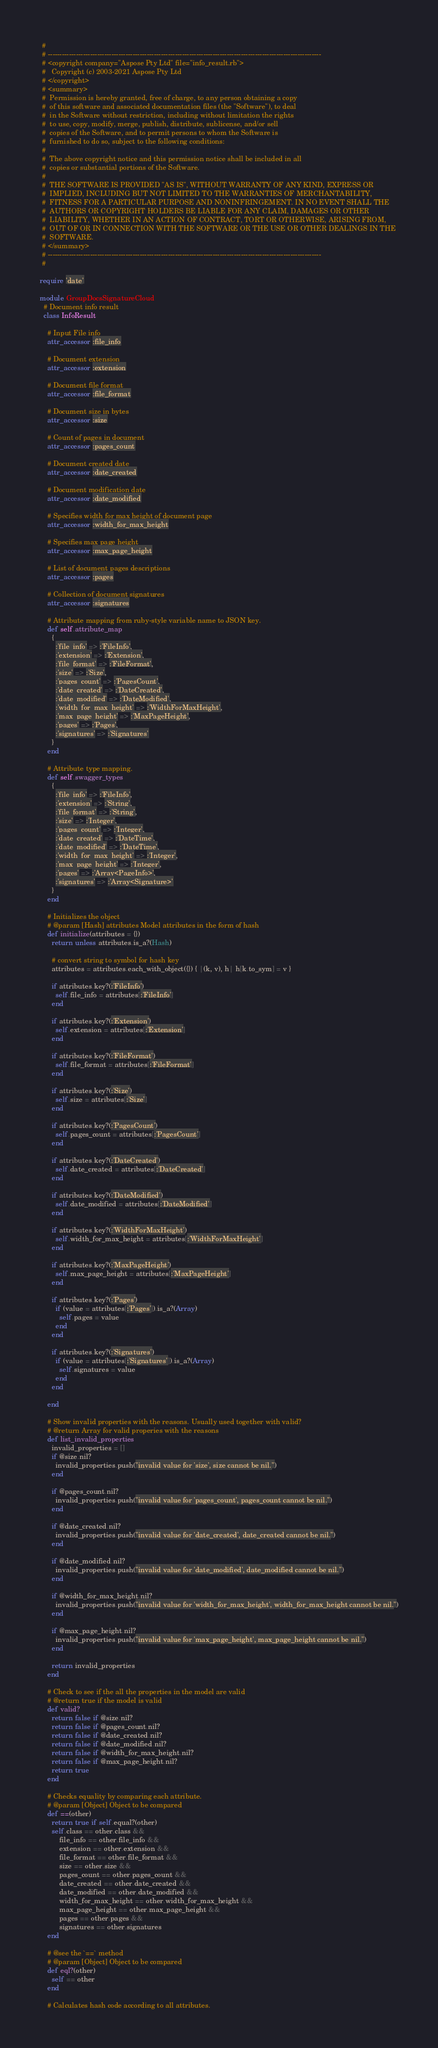Convert code to text. <code><loc_0><loc_0><loc_500><loc_500><_Ruby_> #
 # --------------------------------------------------------------------------------------------------------------------
 # <copyright company="Aspose Pty Ltd" file="info_result.rb">
 #   Copyright (c) 2003-2021 Aspose Pty Ltd
 # </copyright>
 # <summary>
 #  Permission is hereby granted, free of charge, to any person obtaining a copy
 #  of this software and associated documentation files (the "Software"), to deal
 #  in the Software without restriction, including without limitation the rights
 #  to use, copy, modify, merge, publish, distribute, sublicense, and/or sell
 #  copies of the Software, and to permit persons to whom the Software is
 #  furnished to do so, subject to the following conditions:
 #
 #  The above copyright notice and this permission notice shall be included in all
 #  copies or substantial portions of the Software.
 #
 #  THE SOFTWARE IS PROVIDED "AS IS", WITHOUT WARRANTY OF ANY KIND, EXPRESS OR
 #  IMPLIED, INCLUDING BUT NOT LIMITED TO THE WARRANTIES OF MERCHANTABILITY,
 #  FITNESS FOR A PARTICULAR PURPOSE AND NONINFRINGEMENT. IN NO EVENT SHALL THE
 #  AUTHORS OR COPYRIGHT HOLDERS BE LIABLE FOR ANY CLAIM, DAMAGES OR OTHER
 #  LIABILITY, WHETHER IN AN ACTION OF CONTRACT, TORT OR OTHERWISE, ARISING FROM,
 #  OUT OF OR IN CONNECTION WITH THE SOFTWARE OR THE USE OR OTHER DEALINGS IN THE
 #  SOFTWARE.
 # </summary>
 # --------------------------------------------------------------------------------------------------------------------
 #

require 'date'

module GroupDocsSignatureCloud
  # Document info result
  class InfoResult

    # Input File info
    attr_accessor :file_info

    # Document extension
    attr_accessor :extension

    # Document file format
    attr_accessor :file_format

    # Document size in bytes
    attr_accessor :size

    # Count of pages in document
    attr_accessor :pages_count

    # Document created date
    attr_accessor :date_created

    # Document modification date
    attr_accessor :date_modified

    # Specifies width for max height of document page
    attr_accessor :width_for_max_height

    # Specifies max page height
    attr_accessor :max_page_height

    # List of document pages descriptions
    attr_accessor :pages

    # Collection of document signatures
    attr_accessor :signatures

    # Attribute mapping from ruby-style variable name to JSON key.
    def self.attribute_map
      {
        :'file_info' => :'FileInfo',
        :'extension' => :'Extension',
        :'file_format' => :'FileFormat',
        :'size' => :'Size',
        :'pages_count' => :'PagesCount',
        :'date_created' => :'DateCreated',
        :'date_modified' => :'DateModified',
        :'width_for_max_height' => :'WidthForMaxHeight',
        :'max_page_height' => :'MaxPageHeight',
        :'pages' => :'Pages',
        :'signatures' => :'Signatures'
      }
    end

    # Attribute type mapping.
    def self.swagger_types
      {
        :'file_info' => :'FileInfo',
        :'extension' => :'String',
        :'file_format' => :'String',
        :'size' => :'Integer',
        :'pages_count' => :'Integer',
        :'date_created' => :'DateTime',
        :'date_modified' => :'DateTime',
        :'width_for_max_height' => :'Integer',
        :'max_page_height' => :'Integer',
        :'pages' => :'Array<PageInfo>',
        :'signatures' => :'Array<Signature>'
      }
    end

    # Initializes the object
    # @param [Hash] attributes Model attributes in the form of hash
    def initialize(attributes = {})
      return unless attributes.is_a?(Hash)

      # convert string to symbol for hash key
      attributes = attributes.each_with_object({}) { |(k, v), h| h[k.to_sym] = v }

      if attributes.key?(:'FileInfo')
        self.file_info = attributes[:'FileInfo']
      end

      if attributes.key?(:'Extension')
        self.extension = attributes[:'Extension']
      end

      if attributes.key?(:'FileFormat')
        self.file_format = attributes[:'FileFormat']
      end

      if attributes.key?(:'Size')
        self.size = attributes[:'Size']
      end

      if attributes.key?(:'PagesCount')
        self.pages_count = attributes[:'PagesCount']
      end

      if attributes.key?(:'DateCreated')
        self.date_created = attributes[:'DateCreated']
      end

      if attributes.key?(:'DateModified')
        self.date_modified = attributes[:'DateModified']
      end

      if attributes.key?(:'WidthForMaxHeight')
        self.width_for_max_height = attributes[:'WidthForMaxHeight']
      end

      if attributes.key?(:'MaxPageHeight')
        self.max_page_height = attributes[:'MaxPageHeight']
      end

      if attributes.key?(:'Pages')
        if (value = attributes[:'Pages']).is_a?(Array)
          self.pages = value
        end
      end

      if attributes.key?(:'Signatures')
        if (value = attributes[:'Signatures']).is_a?(Array)
          self.signatures = value
        end
      end

    end

    # Show invalid properties with the reasons. Usually used together with valid?
    # @return Array for valid properies with the reasons
    def list_invalid_properties
      invalid_properties = []
      if @size.nil?
        invalid_properties.push("invalid value for 'size', size cannot be nil.")
      end

      if @pages_count.nil?
        invalid_properties.push("invalid value for 'pages_count', pages_count cannot be nil.")
      end

      if @date_created.nil?
        invalid_properties.push("invalid value for 'date_created', date_created cannot be nil.")
      end

      if @date_modified.nil?
        invalid_properties.push("invalid value for 'date_modified', date_modified cannot be nil.")
      end

      if @width_for_max_height.nil?
        invalid_properties.push("invalid value for 'width_for_max_height', width_for_max_height cannot be nil.")
      end

      if @max_page_height.nil?
        invalid_properties.push("invalid value for 'max_page_height', max_page_height cannot be nil.")
      end

      return invalid_properties
    end

    # Check to see if the all the properties in the model are valid
    # @return true if the model is valid
    def valid?
      return false if @size.nil?
      return false if @pages_count.nil?
      return false if @date_created.nil?
      return false if @date_modified.nil?
      return false if @width_for_max_height.nil?
      return false if @max_page_height.nil?
      return true
    end

    # Checks equality by comparing each attribute.
    # @param [Object] Object to be compared
    def ==(other)
      return true if self.equal?(other)
      self.class == other.class &&
          file_info == other.file_info &&
          extension == other.extension &&
          file_format == other.file_format &&
          size == other.size &&
          pages_count == other.pages_count &&
          date_created == other.date_created &&
          date_modified == other.date_modified &&
          width_for_max_height == other.width_for_max_height &&
          max_page_height == other.max_page_height &&
          pages == other.pages &&
          signatures == other.signatures
    end

    # @see the `==` method
    # @param [Object] Object to be compared
    def eql?(other)
      self == other
    end

    # Calculates hash code according to all attributes.</code> 